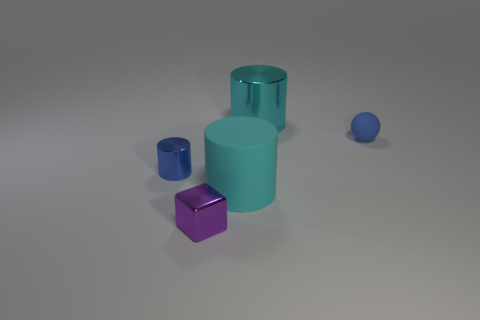What materials do the objects in the image appear to be made from? The objects in the image seem to have a smooth, possibly metallic finish, suggesting they could be made of painted metal or a plastic with a metallic-like coating. 